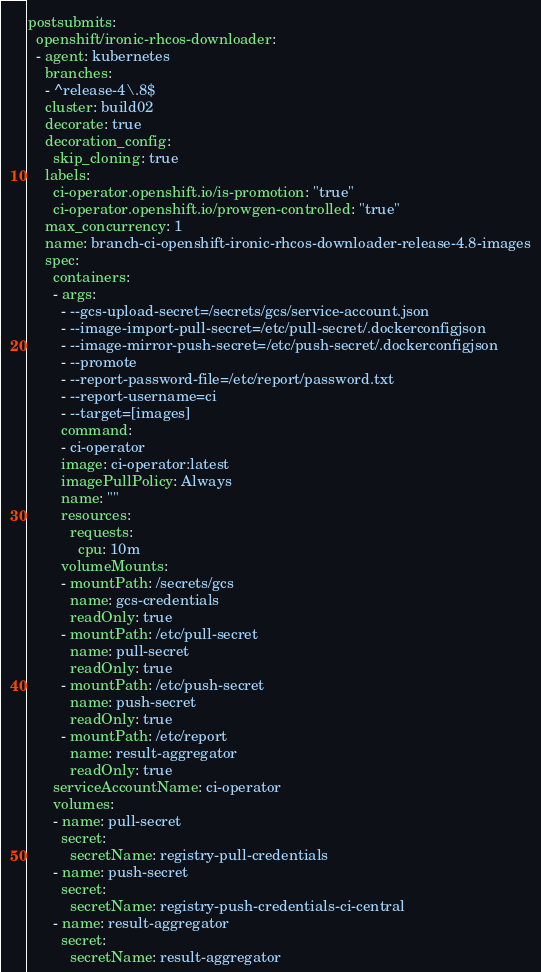<code> <loc_0><loc_0><loc_500><loc_500><_YAML_>postsubmits:
  openshift/ironic-rhcos-downloader:
  - agent: kubernetes
    branches:
    - ^release-4\.8$
    cluster: build02
    decorate: true
    decoration_config:
      skip_cloning: true
    labels:
      ci-operator.openshift.io/is-promotion: "true"
      ci-operator.openshift.io/prowgen-controlled: "true"
    max_concurrency: 1
    name: branch-ci-openshift-ironic-rhcos-downloader-release-4.8-images
    spec:
      containers:
      - args:
        - --gcs-upload-secret=/secrets/gcs/service-account.json
        - --image-import-pull-secret=/etc/pull-secret/.dockerconfigjson
        - --image-mirror-push-secret=/etc/push-secret/.dockerconfigjson
        - --promote
        - --report-password-file=/etc/report/password.txt
        - --report-username=ci
        - --target=[images]
        command:
        - ci-operator
        image: ci-operator:latest
        imagePullPolicy: Always
        name: ""
        resources:
          requests:
            cpu: 10m
        volumeMounts:
        - mountPath: /secrets/gcs
          name: gcs-credentials
          readOnly: true
        - mountPath: /etc/pull-secret
          name: pull-secret
          readOnly: true
        - mountPath: /etc/push-secret
          name: push-secret
          readOnly: true
        - mountPath: /etc/report
          name: result-aggregator
          readOnly: true
      serviceAccountName: ci-operator
      volumes:
      - name: pull-secret
        secret:
          secretName: registry-pull-credentials
      - name: push-secret
        secret:
          secretName: registry-push-credentials-ci-central
      - name: result-aggregator
        secret:
          secretName: result-aggregator
</code> 